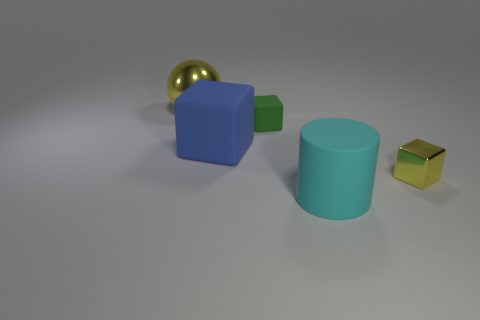Subtract all green spheres. Subtract all yellow blocks. How many spheres are left? 1 Add 5 small brown objects. How many objects exist? 10 Subtract all cylinders. How many objects are left? 4 Add 3 small green rubber things. How many small green rubber things exist? 4 Subtract 0 brown balls. How many objects are left? 5 Subtract all small brown cylinders. Subtract all big cubes. How many objects are left? 4 Add 4 small metal objects. How many small metal objects are left? 5 